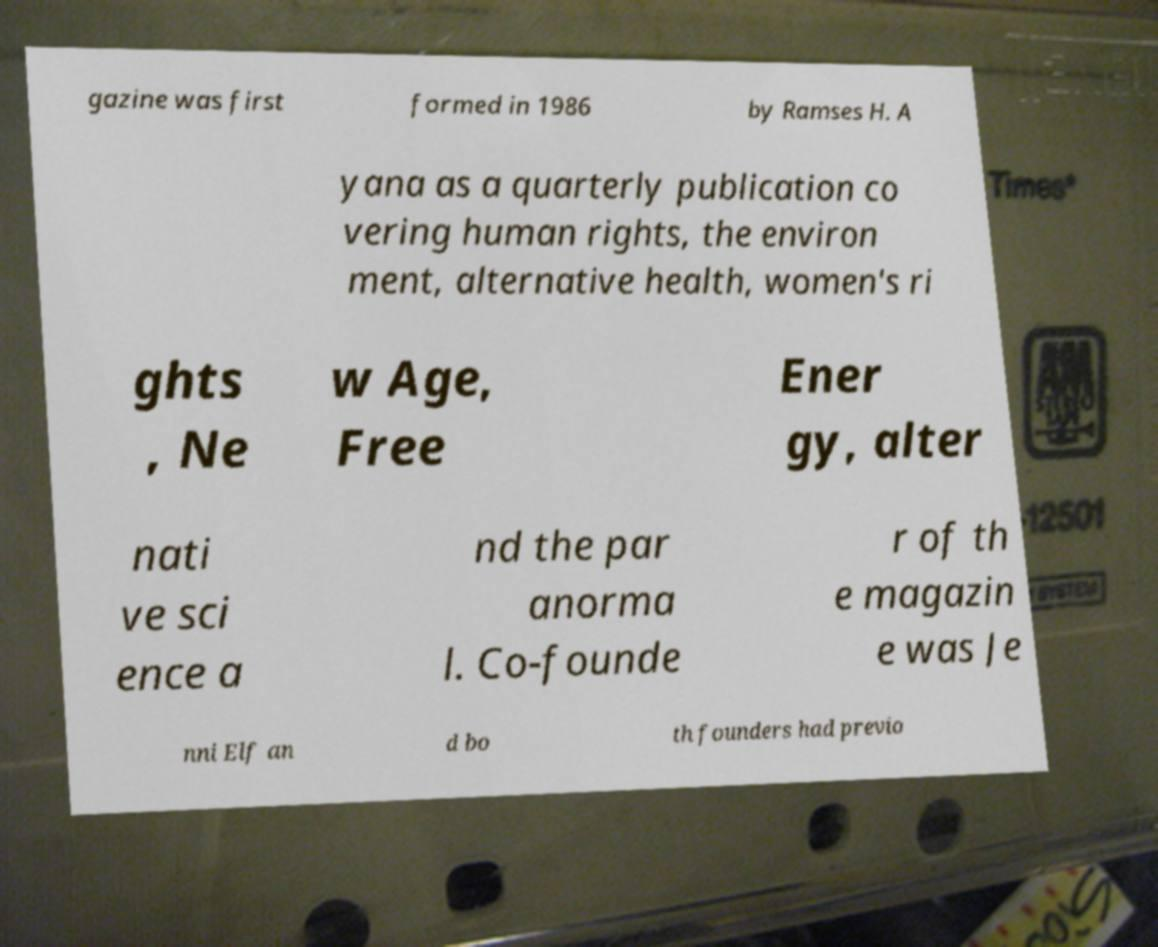Please read and relay the text visible in this image. What does it say? gazine was first formed in 1986 by Ramses H. A yana as a quarterly publication co vering human rights, the environ ment, alternative health, women's ri ghts , Ne w Age, Free Ener gy, alter nati ve sci ence a nd the par anorma l. Co-founde r of th e magazin e was Je nni Elf an d bo th founders had previo 